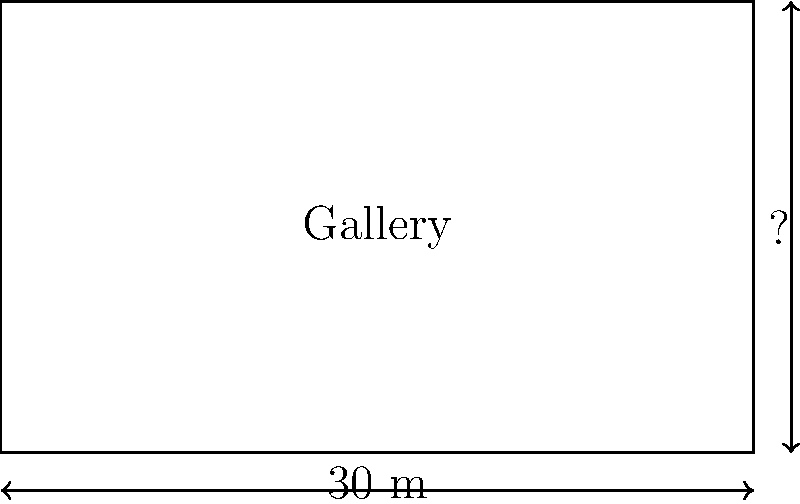As the supportive sibling who helped finance your artist sibling's first solo exhibition, you're now assisting with the gallery layout. The rectangular gallery space has a total area of 180 square meters, and its width is 30 meters. What is the length of the gallery? Let's approach this step-by-step:

1) We know that the area of a rectangle is given by the formula:
   $$ \text{Area} = \text{Width} \times \text{Length} $$

2) We are given that:
   - The total area is 180 square meters
   - The width is 30 meters

3) Let's substitute these values into our formula:
   $$ 180 = 30 \times \text{Length} $$

4) To solve for the length, we divide both sides by 30:
   $$ \frac{180}{30} = \text{Length} $$

5) Simplifying:
   $$ 6 = \text{Length} $$

Therefore, the length of the gallery is 6 meters.
Answer: 6 meters 